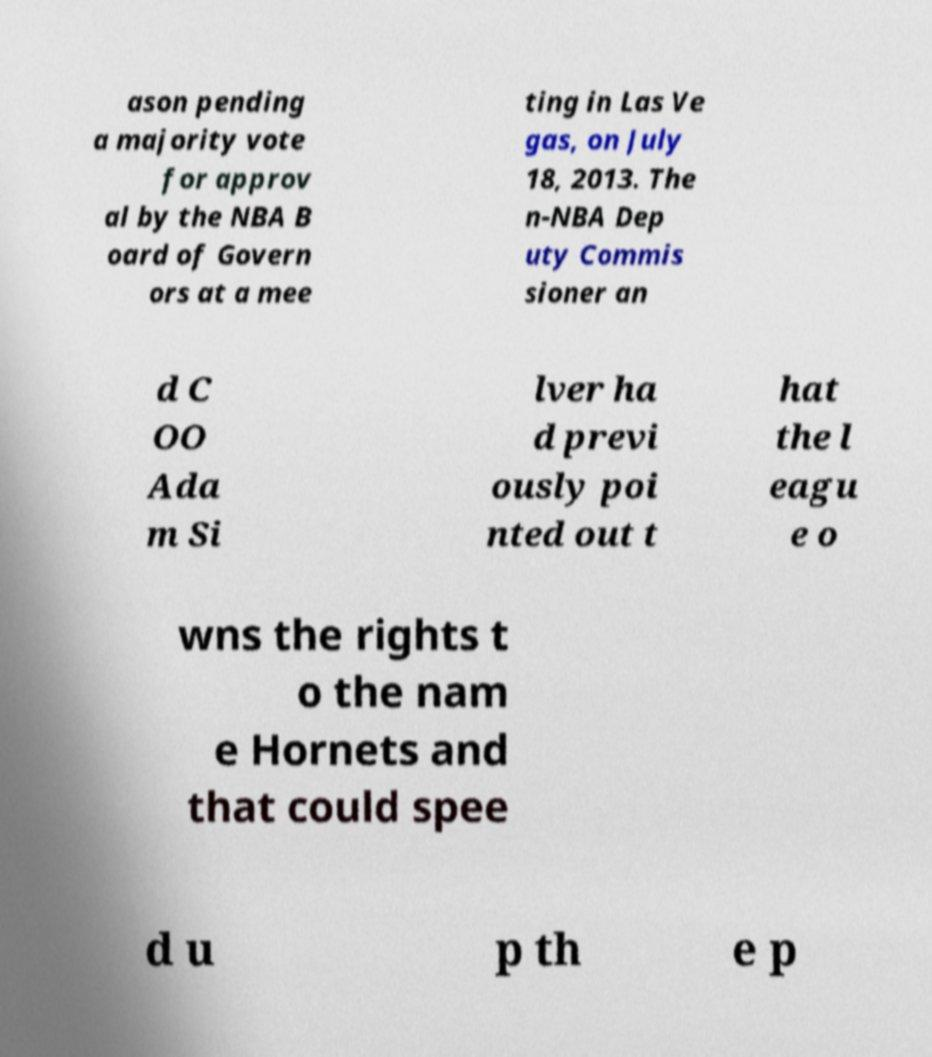What messages or text are displayed in this image? I need them in a readable, typed format. ason pending a majority vote for approv al by the NBA B oard of Govern ors at a mee ting in Las Ve gas, on July 18, 2013. The n-NBA Dep uty Commis sioner an d C OO Ada m Si lver ha d previ ously poi nted out t hat the l eagu e o wns the rights t o the nam e Hornets and that could spee d u p th e p 